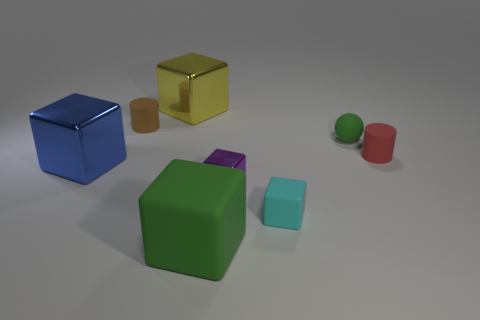Subtract all large metal cubes. How many cubes are left? 3 Subtract all blue cubes. How many cubes are left? 4 Add 1 cyan shiny spheres. How many objects exist? 9 Subtract all cylinders. How many objects are left? 6 Add 6 metallic things. How many metallic things are left? 9 Add 5 big cyan metal spheres. How many big cyan metal spheres exist? 5 Subtract 0 gray balls. How many objects are left? 8 Subtract 3 cubes. How many cubes are left? 2 Subtract all yellow spheres. Subtract all red cylinders. How many spheres are left? 1 Subtract all blue balls. How many cyan cylinders are left? 0 